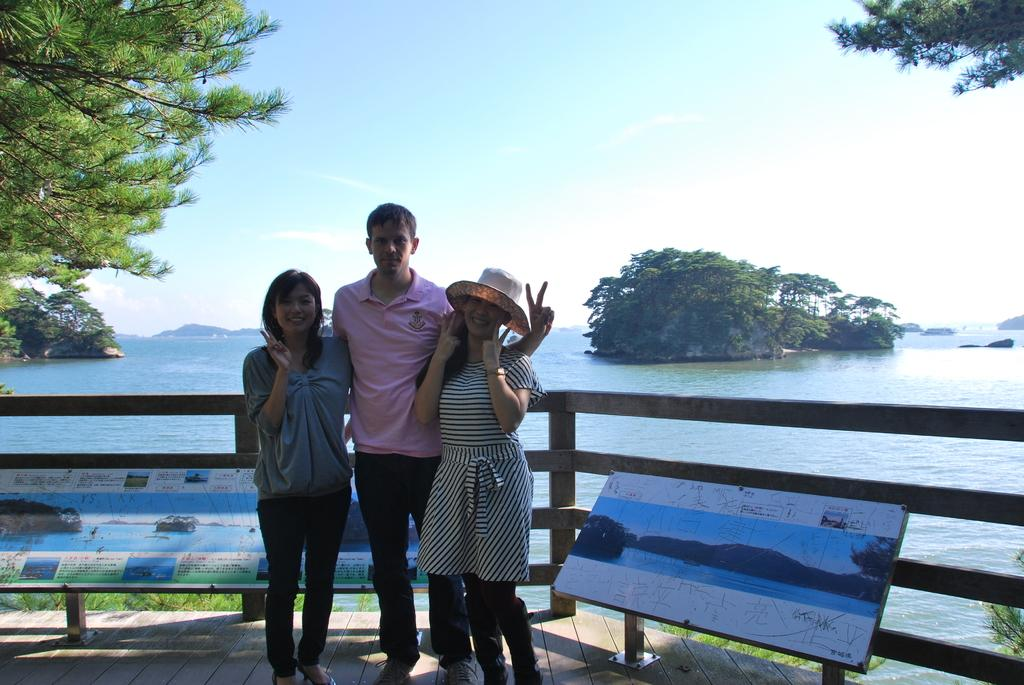How many people are present in the image? There are three people standing in the center of the image. What can be seen in the background of the image? There is water visible in the background of the image. What type of fencing is present in the image? There is a wooden fencing in the image. What type of vegetation is visible in the image? There are trees in the image. What type of account is being discussed by the people in the image? There is no indication in the image that the people are discussing any type of account. 